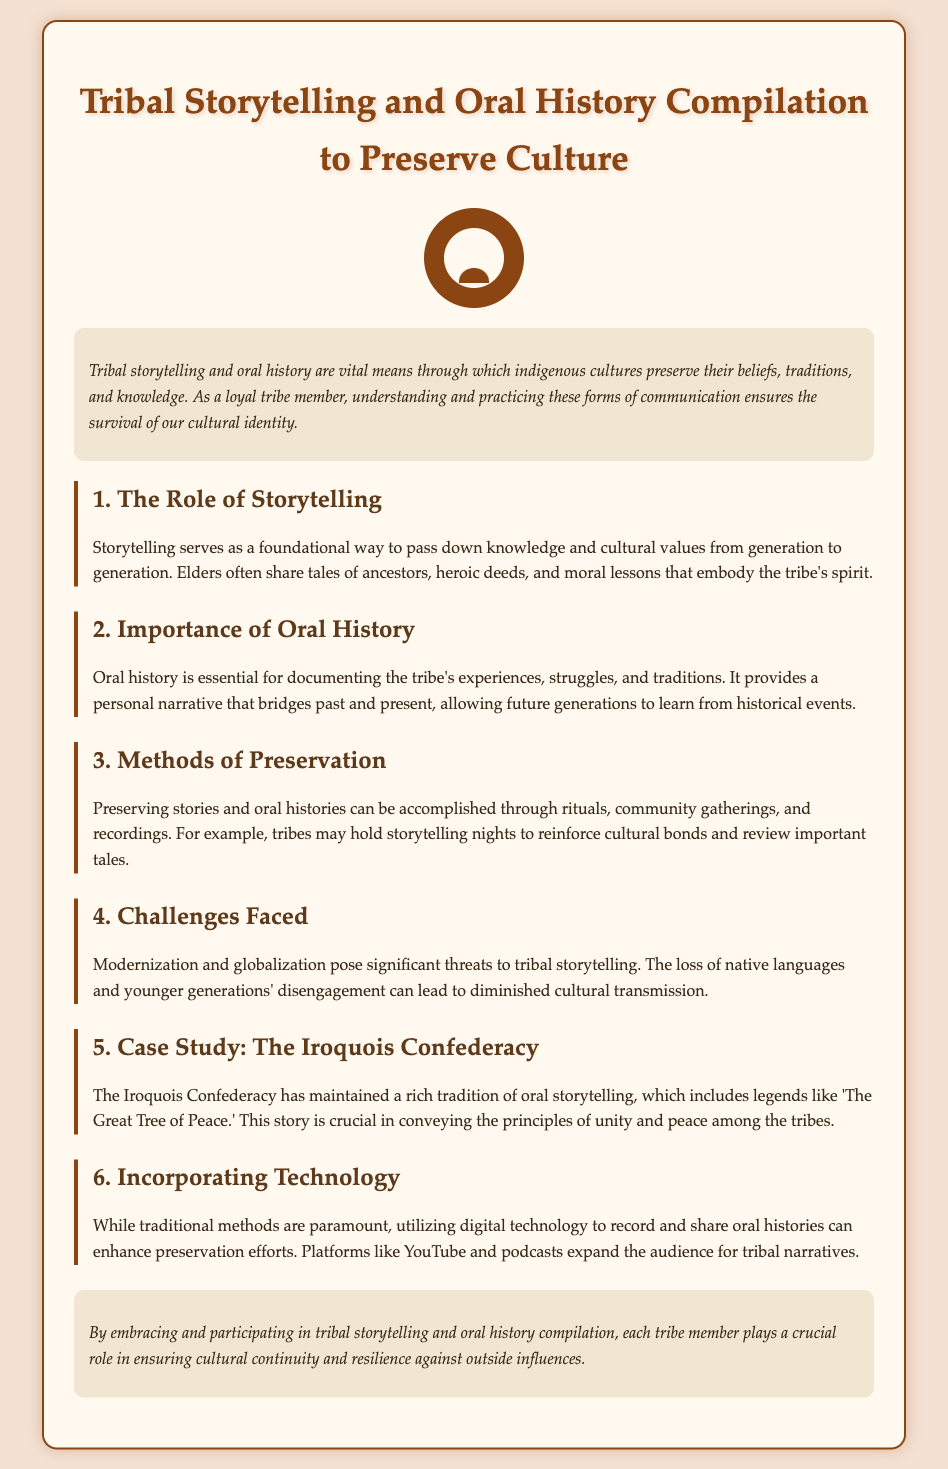What is the primary means of cultural preservation mentioned? The document states that storytelling and oral history are vital means for preserving culture.
Answer: storytelling and oral history Who typically shares tales in tribal storytelling? The document indicates that elders often share tales of ancestors and heroic deeds.
Answer: elders What does oral history provide according to the document? The importance of oral history is described as providing a personal narrative that bridges past and present.
Answer: personal narrative What significant challenge to storytelling is highlighted? The document mentions that modernization and globalization pose threats to tribal storytelling.
Answer: modernization and globalization Which case study is presented in the document? The document specifically discusses the Iroquois Confederacy as a case study.
Answer: Iroquois Confederacy What method is suggested for preserving stories? The document recommends community gatherings as a method for preserving stories.
Answer: community gatherings How can technology aid in preservation efforts? The document states that utilizing digital technology can enhance preservation efforts by recording and sharing histories.
Answer: digital technology What cultural principle does 'The Great Tree of Peace' convey? The document notes that this story conveys principles of unity and peace.
Answer: unity and peace What is the role of storytelling nights in the tribe? The document describes storytelling nights as a way to reinforce cultural bonds.
Answer: reinforce cultural bonds 